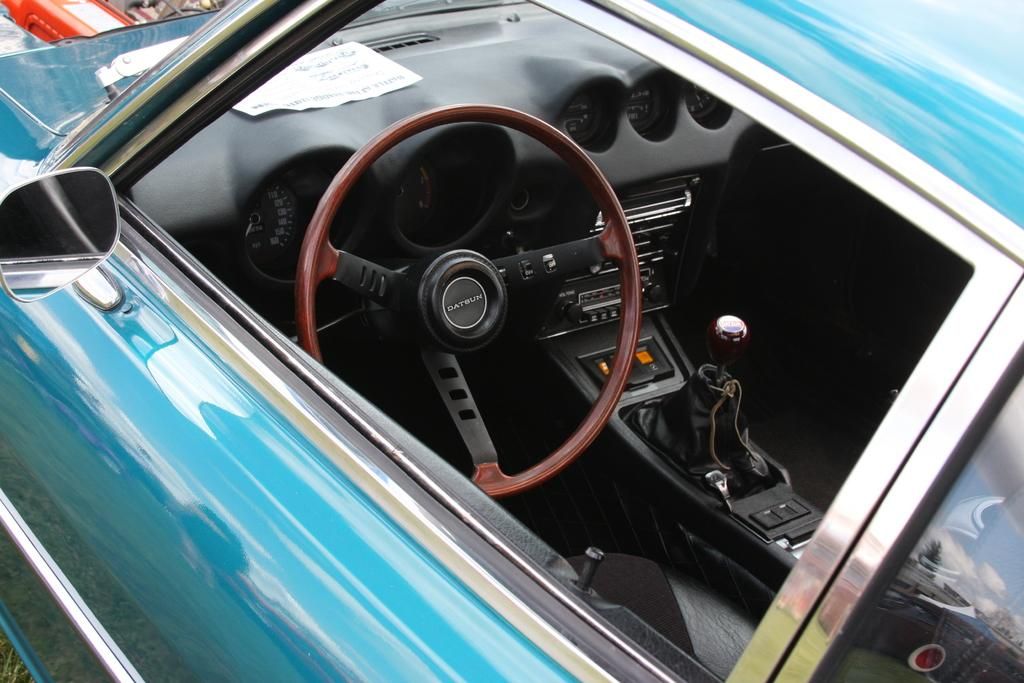What is the main subject of the picture? The main subject of the picture is a car. What can be seen in the center of the picture? The steering, a speedometer, and the gear rod are visible in the center of the picture. Is there a seat in the car? Yes, there is a seat in the car. What feature is present on the left side of the car? A side view mirror is present on the left side of the car. What type of meat is being cooked in the car's engine in the image? There is no meat or cooking activity present in the image; it features a car with various visible components. 